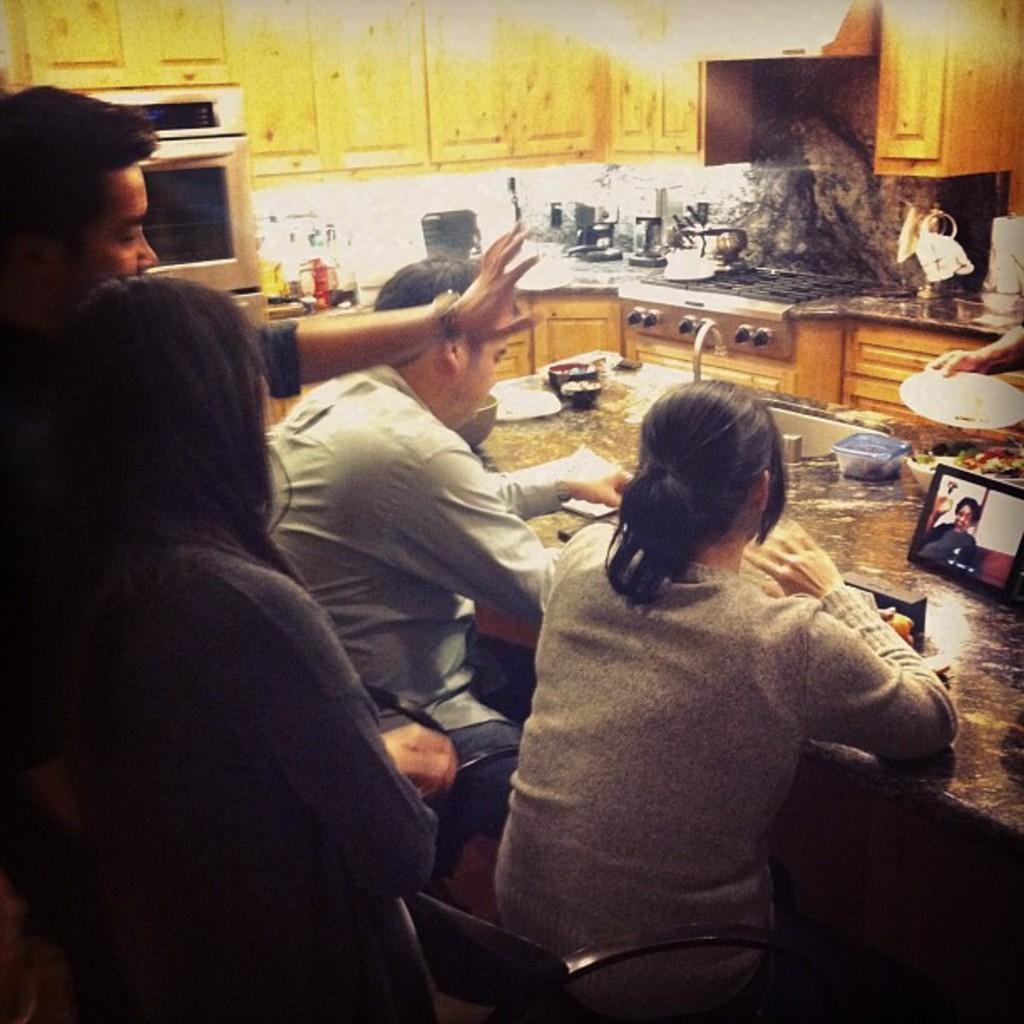How would you summarize this image in a sentence or two? This is the picture of the kitchen. There are four people, two are sitting and two are standing. There are bowl, plates, box and tab on the table. At the back there are utensils on the desk. At the left there is a micro oven. 